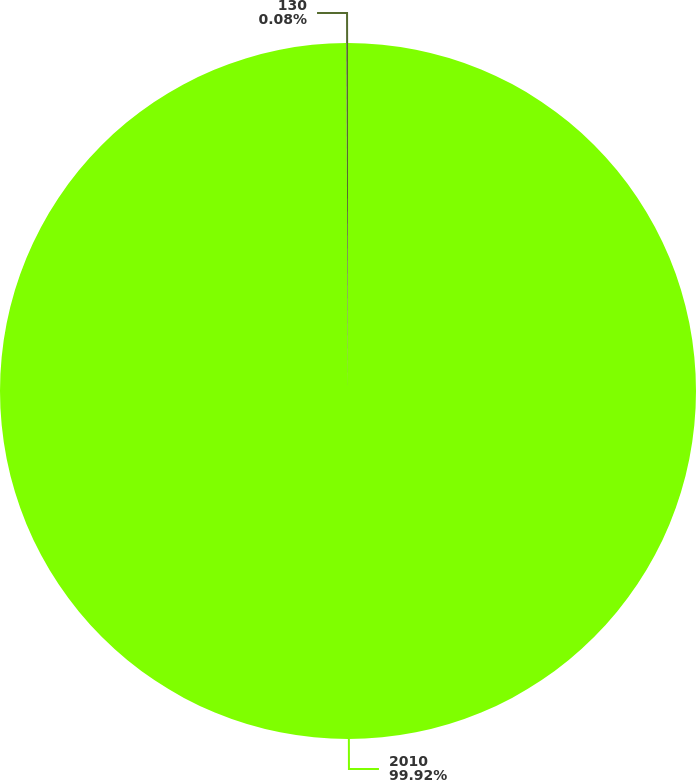<chart> <loc_0><loc_0><loc_500><loc_500><pie_chart><fcel>2010<fcel>130<nl><fcel>99.92%<fcel>0.08%<nl></chart> 